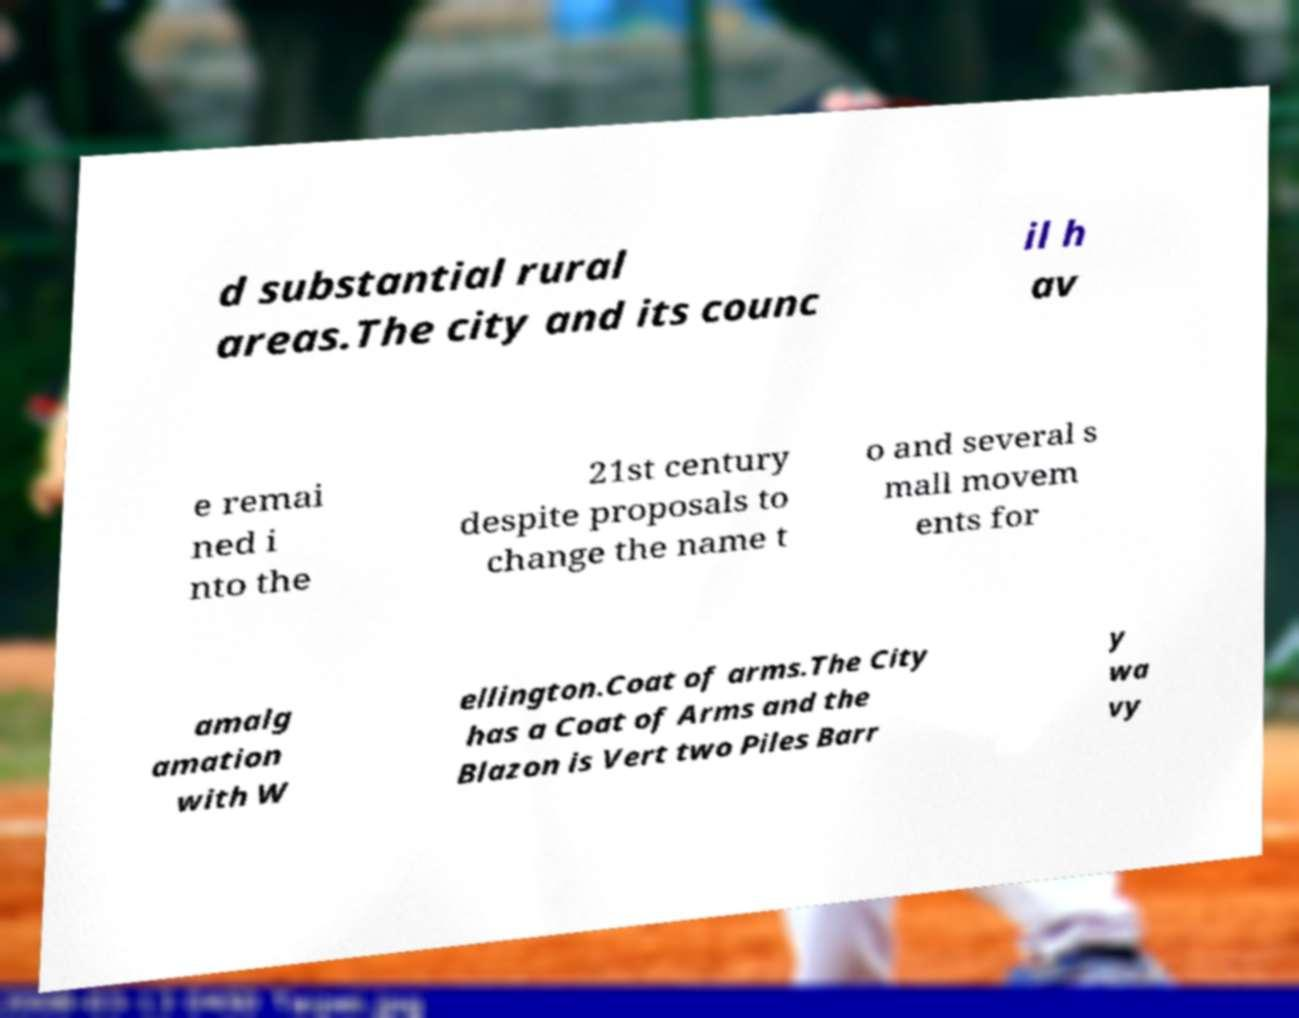Please read and relay the text visible in this image. What does it say? d substantial rural areas.The city and its counc il h av e remai ned i nto the 21st century despite proposals to change the name t o and several s mall movem ents for amalg amation with W ellington.Coat of arms.The City has a Coat of Arms and the Blazon is Vert two Piles Barr y wa vy 